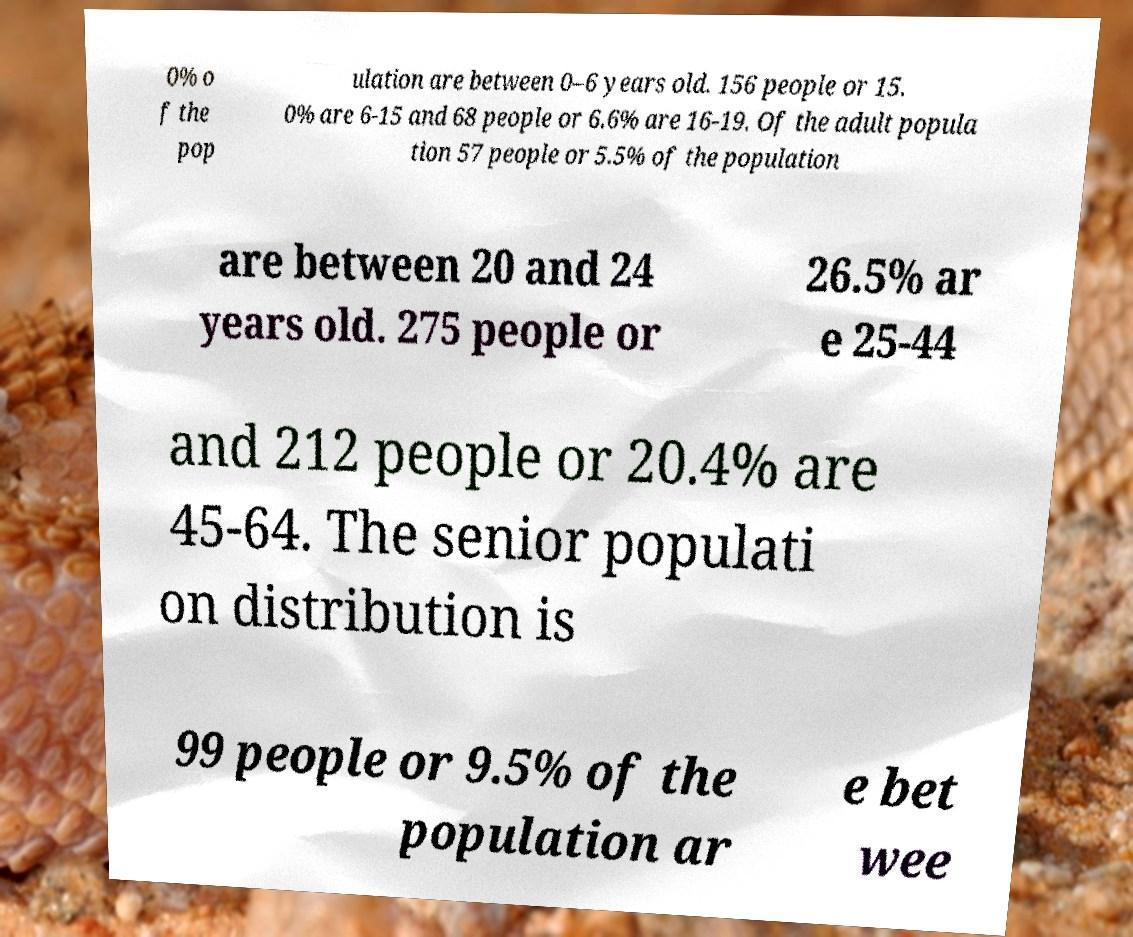Can you accurately transcribe the text from the provided image for me? 0% o f the pop ulation are between 0–6 years old. 156 people or 15. 0% are 6-15 and 68 people or 6.6% are 16-19. Of the adult popula tion 57 people or 5.5% of the population are between 20 and 24 years old. 275 people or 26.5% ar e 25-44 and 212 people or 20.4% are 45-64. The senior populati on distribution is 99 people or 9.5% of the population ar e bet wee 